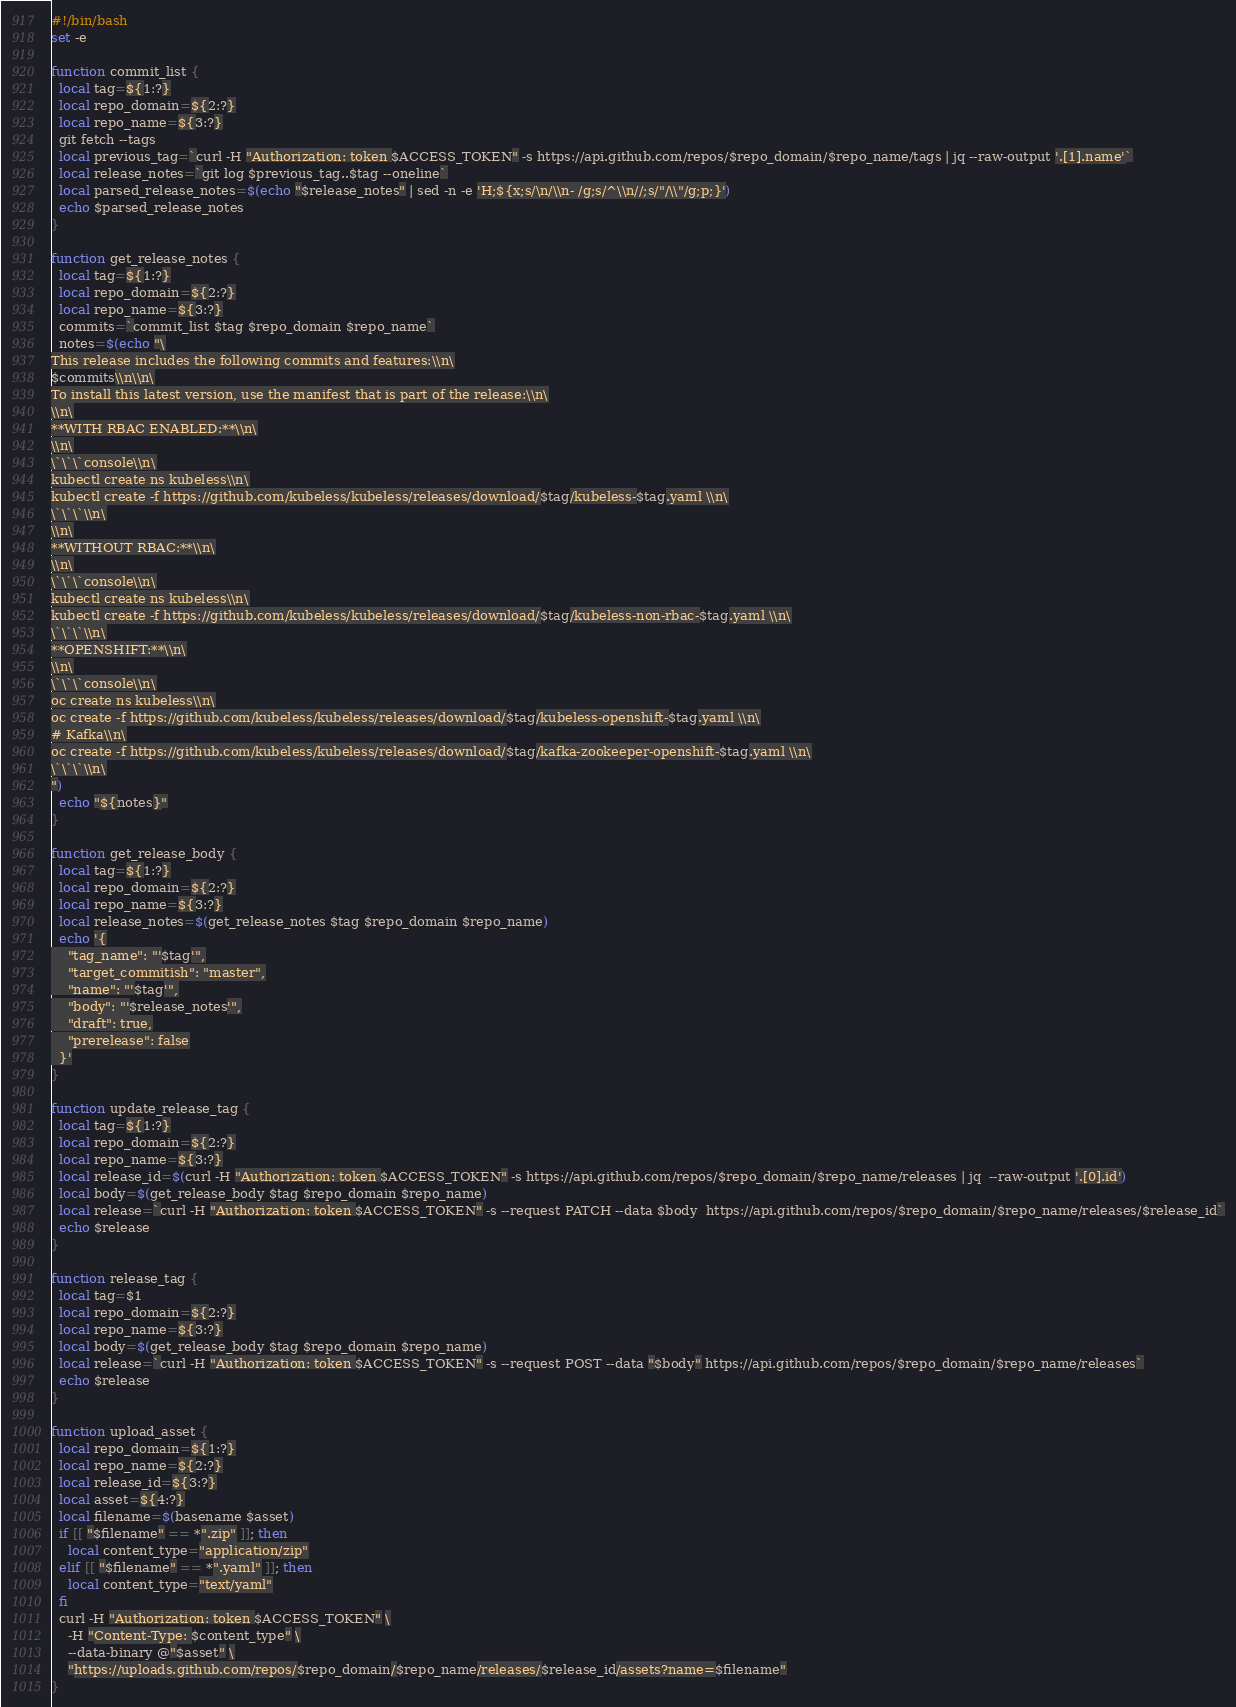<code> <loc_0><loc_0><loc_500><loc_500><_Bash_>#!/bin/bash
set -e

function commit_list {
  local tag=${1:?}
  local repo_domain=${2:?}
  local repo_name=${3:?}
  git fetch --tags
  local previous_tag=`curl -H "Authorization: token $ACCESS_TOKEN" -s https://api.github.com/repos/$repo_domain/$repo_name/tags | jq --raw-output '.[1].name'`
  local release_notes=`git log $previous_tag..$tag --oneline`
  local parsed_release_notes=$(echo "$release_notes" | sed -n -e 'H;${x;s/\n/\\n- /g;s/^\\n//;s/"/\\"/g;p;}')
  echo $parsed_release_notes
}

function get_release_notes {
  local tag=${1:?}
  local repo_domain=${2:?}
  local repo_name=${3:?}
  commits=`commit_list $tag $repo_domain $repo_name`
  notes=$(echo "\
This release includes the following commits and features:\\n\
$commits\\n\\n\
To install this latest version, use the manifest that is part of the release:\\n\
\\n\
**WITH RBAC ENABLED:**\\n\
\\n\
\`\`\`console\\n\
kubectl create ns kubeless\\n\
kubectl create -f https://github.com/kubeless/kubeless/releases/download/$tag/kubeless-$tag.yaml \\n\
\`\`\`\\n\
\\n\
**WITHOUT RBAC:**\\n\
\\n\
\`\`\`console\\n\
kubectl create ns kubeless\\n\
kubectl create -f https://github.com/kubeless/kubeless/releases/download/$tag/kubeless-non-rbac-$tag.yaml \\n\
\`\`\`\\n\
**OPENSHIFT:**\\n\
\\n\
\`\`\`console\\n\
oc create ns kubeless\\n\
oc create -f https://github.com/kubeless/kubeless/releases/download/$tag/kubeless-openshift-$tag.yaml \\n\
# Kafka\\n\
oc create -f https://github.com/kubeless/kubeless/releases/download/$tag/kafka-zookeeper-openshift-$tag.yaml \\n\
\`\`\`\\n\
")
  echo "${notes}"
}

function get_release_body {
  local tag=${1:?}
  local repo_domain=${2:?}
  local repo_name=${3:?}
  local release_notes=$(get_release_notes $tag $repo_domain $repo_name)
  echo '{
    "tag_name": "'$tag'",
    "target_commitish": "master",
    "name": "'$tag'",
    "body": "'$release_notes'",
    "draft": true,
    "prerelease": false
  }'
}

function update_release_tag {
  local tag=${1:?}
  local repo_domain=${2:?}
  local repo_name=${3:?}
  local release_id=$(curl -H "Authorization: token $ACCESS_TOKEN" -s https://api.github.com/repos/$repo_domain/$repo_name/releases | jq  --raw-output '.[0].id')
  local body=$(get_release_body $tag $repo_domain $repo_name)
  local release=`curl -H "Authorization: token $ACCESS_TOKEN" -s --request PATCH --data $body  https://api.github.com/repos/$repo_domain/$repo_name/releases/$release_id`
  echo $release
}

function release_tag {
  local tag=$1
  local repo_domain=${2:?}
  local repo_name=${3:?}
  local body=$(get_release_body $tag $repo_domain $repo_name)
  local release=`curl -H "Authorization: token $ACCESS_TOKEN" -s --request POST --data "$body" https://api.github.com/repos/$repo_domain/$repo_name/releases`
  echo $release
}

function upload_asset {
  local repo_domain=${1:?}
  local repo_name=${2:?}
  local release_id=${3:?}
  local asset=${4:?}
  local filename=$(basename $asset)
  if [[ "$filename" == *".zip" ]]; then
    local content_type="application/zip"
  elif [[ "$filename" == *".yaml" ]]; then
    local content_type="text/yaml"
  fi
  curl -H "Authorization: token $ACCESS_TOKEN" \
    -H "Content-Type: $content_type" \
    --data-binary @"$asset" \
    "https://uploads.github.com/repos/$repo_domain/$repo_name/releases/$release_id/assets?name=$filename"
}
</code> 